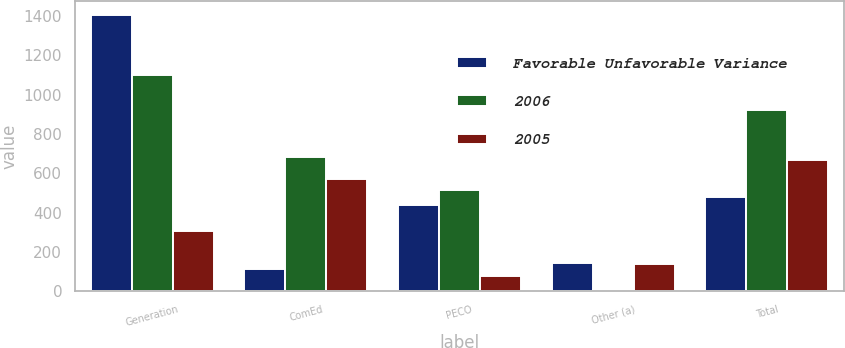Convert chart. <chart><loc_0><loc_0><loc_500><loc_500><stacked_bar_chart><ecel><fcel>Generation<fcel>ComEd<fcel>PECO<fcel>Other (a)<fcel>Total<nl><fcel>Favorable Unfavorable Variance<fcel>1407<fcel>112<fcel>441<fcel>144<fcel>479<nl><fcel>2006<fcel>1098<fcel>685<fcel>517<fcel>7<fcel>923<nl><fcel>2005<fcel>309<fcel>573<fcel>76<fcel>137<fcel>669<nl></chart> 